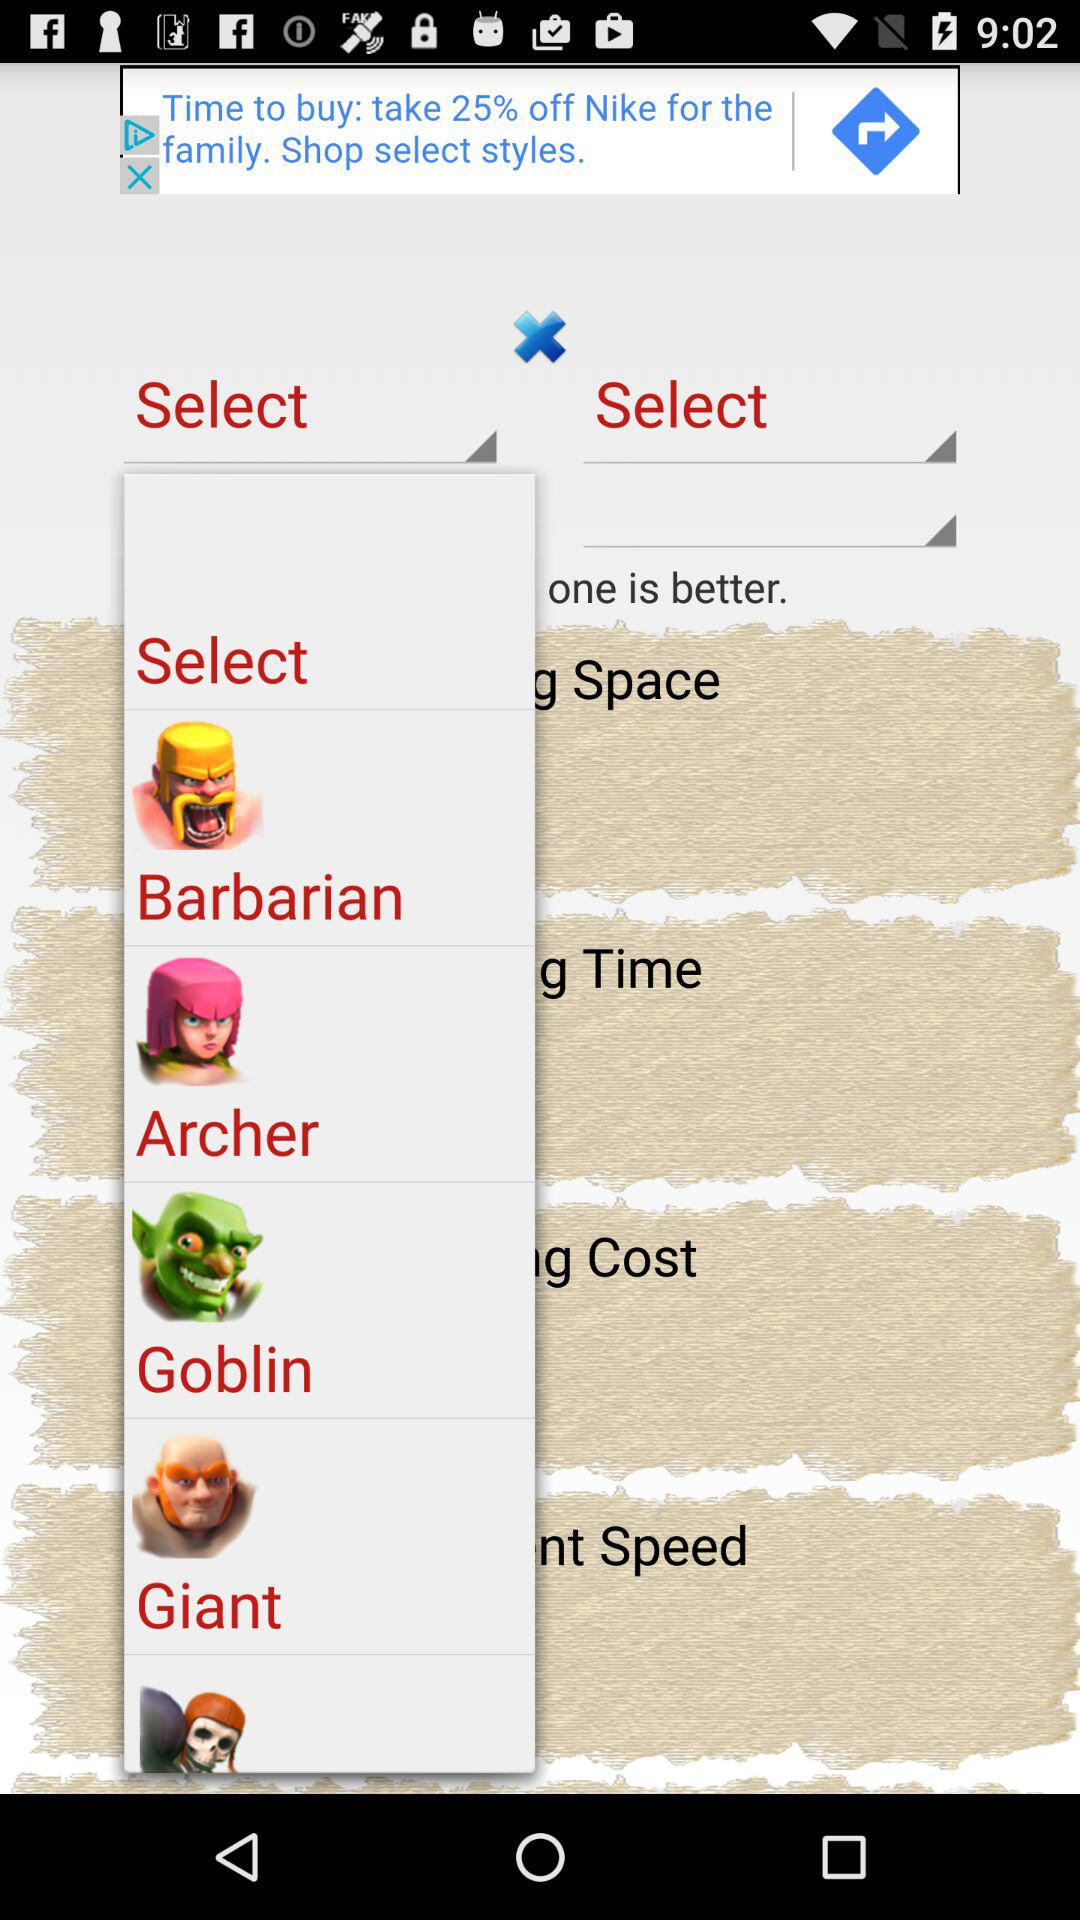Time is the feature of which cartoon series?
When the provided information is insufficient, respond with <no answer>. <no answer> 